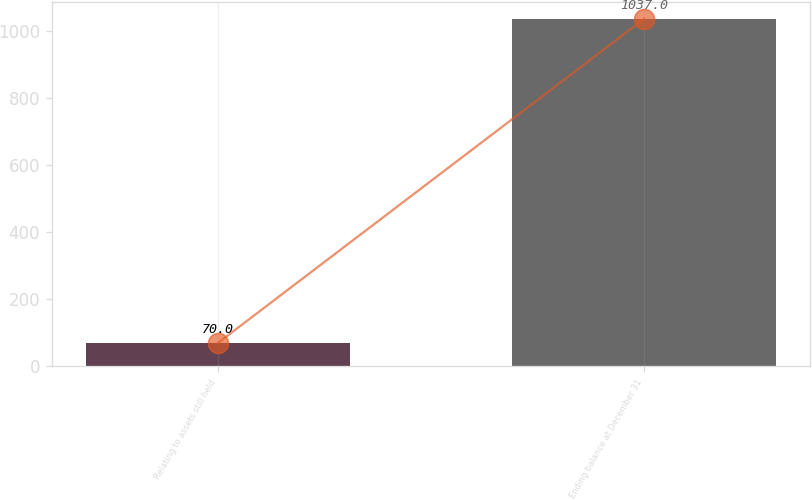Convert chart. <chart><loc_0><loc_0><loc_500><loc_500><bar_chart><fcel>Relating to assets still held<fcel>Ending balance at December 31<nl><fcel>70<fcel>1037<nl></chart> 